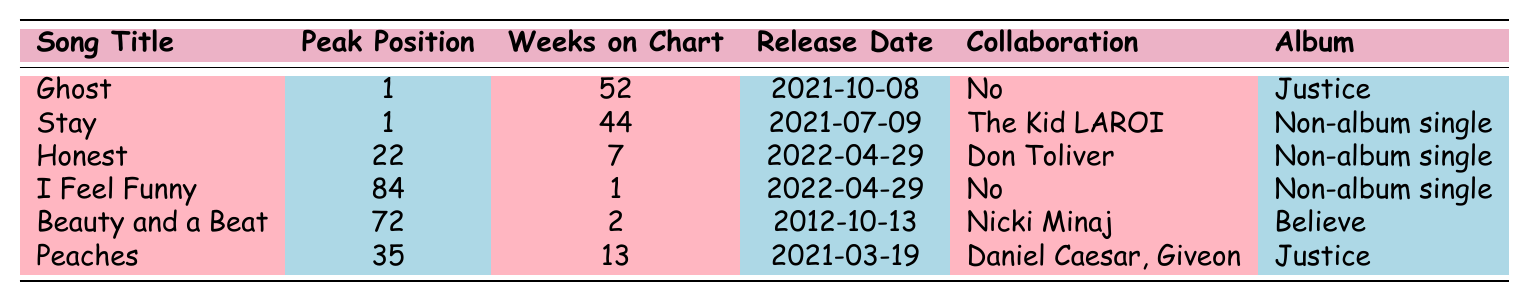What was the peak position of the song "Ghost"? The table lists the peak position for "Ghost" as 1, indicating it reached the top of the chart.
Answer: 1 How many weeks did "Stay" remain on the Billboard Hot 100 chart? According to the table, "Stay" remained on the chart for 44 weeks.
Answer: 44 Is "Honest" a collaboration? The table specifies that "Honest" features a collaboration with Don Toliver, therefore it is a collaboration.
Answer: Yes What was the release date of "I Feel Funny"? The release date for "I Feel Funny" is provided in the table as April 29, 2022.
Answer: 2022-04-29 Which song had a peak position lower than 35? From the table, "I Feel Funny" peaked at position 84, while "Honest" peaked at 22, both are lower than 35.
Answer: I Feel Funny How many weeks did "Peaches" chart compared to "Honest"? "Peaches" charted for 13 weeks, while "Honest" charted for 7 weeks. The difference is 13 - 7 = 6 weeks.
Answer: 6 weeks What is the average peak position of all the listed songs? First, we sum the peak positions: 1 + 1 + 22 + 84 + 72 + 35 = 215. There are 6 songs, so the average is 215 / 6 ≈ 35.83.
Answer: 35.83 Is "Beauty and a Beat" included in the 2022 chart performance? The table shows the release date of "Beauty and a Beat" as 2012, so it is not part of the 2022 performances.
Answer: No How many collaborations are in the table? There are 3 songs that feature collaborations: "Stay," "Honest," and "Beauty and a Beat."
Answer: 3 Which song has the highest number of weeks on the chart and what is that number? "Ghost" has the highest number of weeks on the chart, totaling 52 weeks.
Answer: 52 